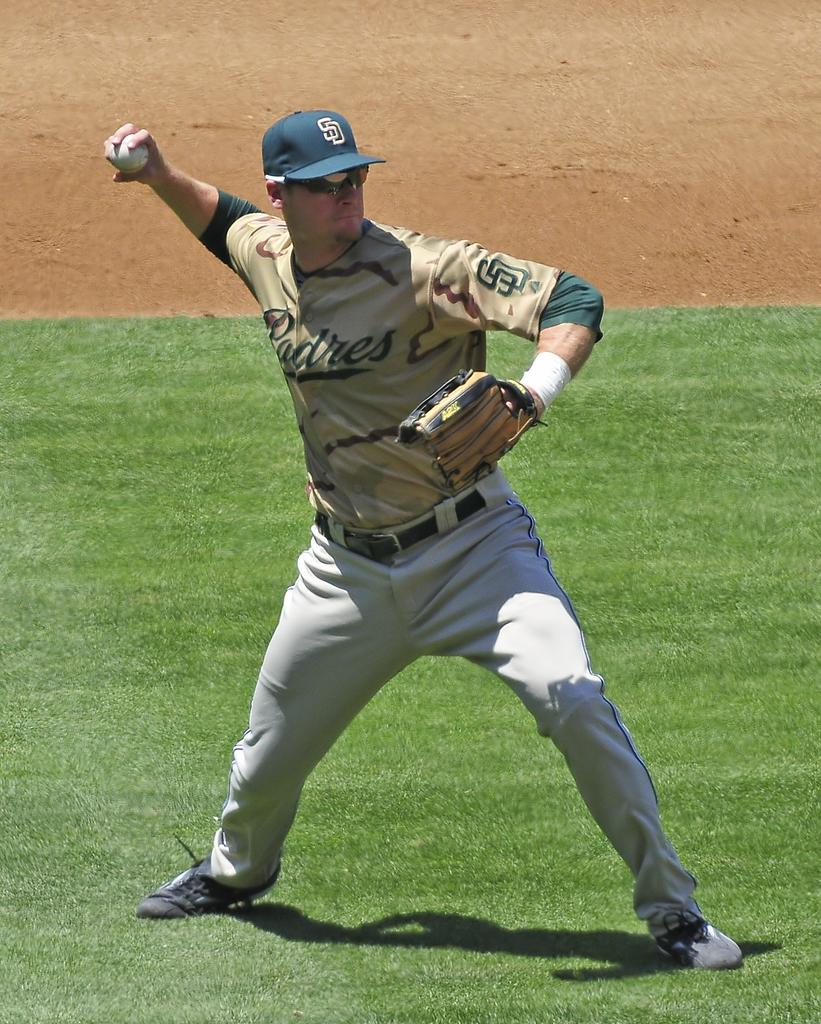<image>
Give a short and clear explanation of the subsequent image. Baseball player pitching the ball for hte Padres. 